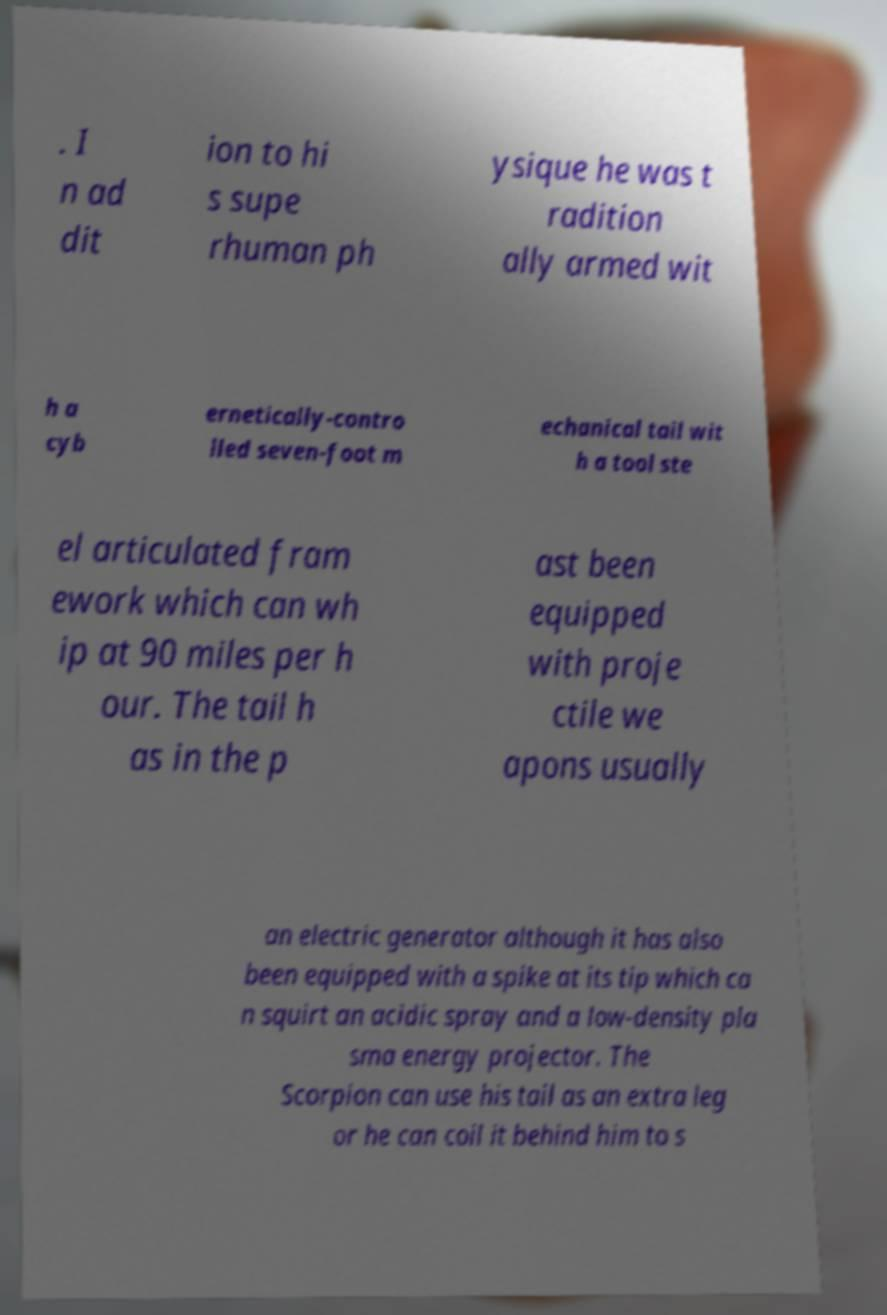Could you extract and type out the text from this image? . I n ad dit ion to hi s supe rhuman ph ysique he was t radition ally armed wit h a cyb ernetically-contro lled seven-foot m echanical tail wit h a tool ste el articulated fram ework which can wh ip at 90 miles per h our. The tail h as in the p ast been equipped with proje ctile we apons usually an electric generator although it has also been equipped with a spike at its tip which ca n squirt an acidic spray and a low-density pla sma energy projector. The Scorpion can use his tail as an extra leg or he can coil it behind him to s 